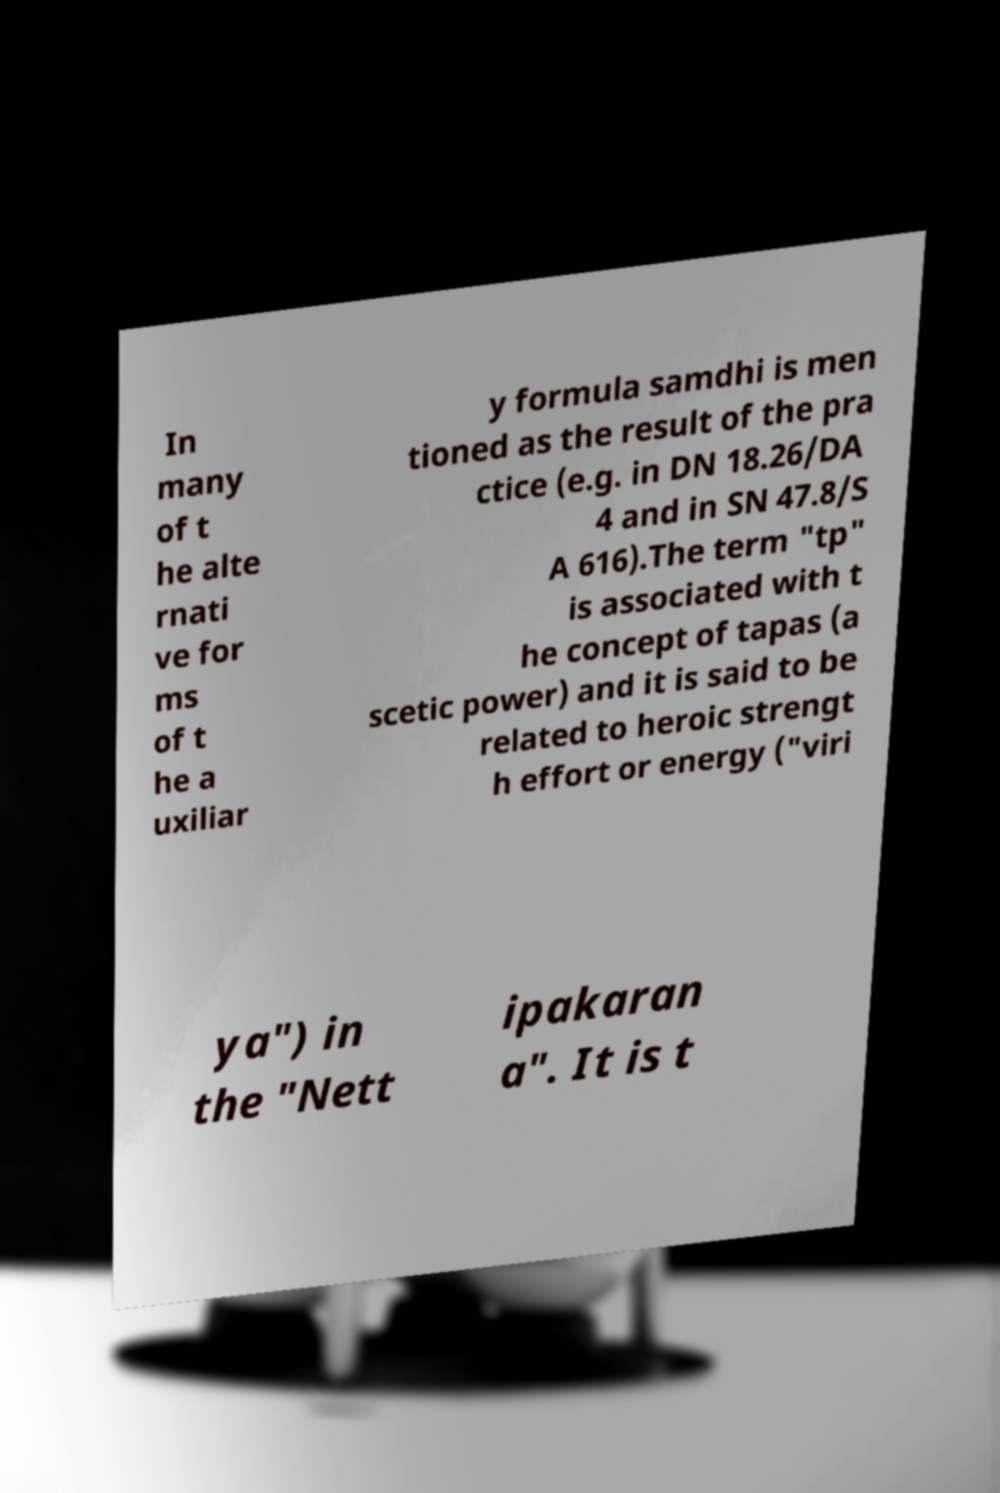Can you accurately transcribe the text from the provided image for me? In many of t he alte rnati ve for ms of t he a uxiliar y formula samdhi is men tioned as the result of the pra ctice (e.g. in DN 18.26/DA 4 and in SN 47.8/S A 616).The term "tp" is associated with t he concept of tapas (a scetic power) and it is said to be related to heroic strengt h effort or energy ("viri ya") in the "Nett ipakaran a". It is t 